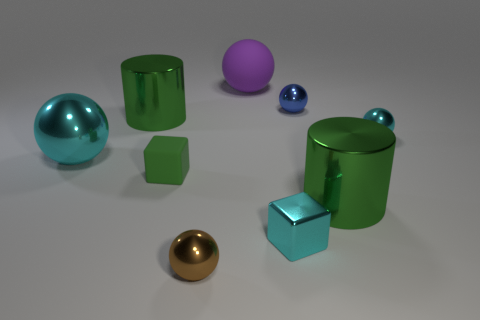Subtract all red cubes. How many cyan balls are left? 2 Subtract all cyan spheres. How many spheres are left? 3 Subtract 3 balls. How many balls are left? 2 Subtract all large purple spheres. How many spheres are left? 4 Subtract all blocks. How many objects are left? 7 Subtract all green balls. Subtract all blue cylinders. How many balls are left? 5 Add 1 purple matte cubes. How many purple matte cubes exist? 1 Subtract 2 cyan spheres. How many objects are left? 7 Subtract all brown rubber blocks. Subtract all balls. How many objects are left? 4 Add 7 tiny blue objects. How many tiny blue objects are left? 8 